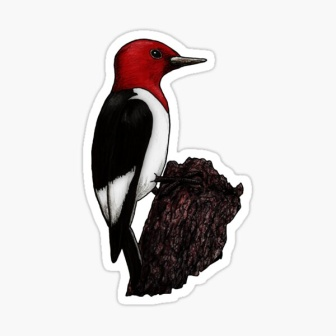What can you infer about the environment from the image? From the detailed depiction of the woodpecker and the tree stump, we can infer that the environment is a natural, lively forest likely abundant with various forms of wildlife. The presence of the woodpecker, which is usually found in wooded areas, suggests that there are plenty of trees, branches, and sources of food such as insects. The textured and aged appearance of the tree stump implies a mature forest setting, where trees have been growing and cycling through life stages for many years. The overall harmony between the bird and its perching stump suggests a peaceful and balanced ecosystem, likely teeming with flora and fauna. What if the woodpecker had a mystical adventure? Describe its journey fully. In a time not far removed from the whispers of legend, Ruby the red-headed woodpecker embarked on an extraordinary adventure. One misty morning, as she pecked on her favorite tree stump, she discovered a hidden path illuminated by a soft, otherworldly glow. Curiosity piqued, Ruby followed this shimmering trail, and soon found herself in an enchanted forest. This was no ordinary forest; the trees were enormous, their branches entwined to form a living canopy that glittered with bioluminescent flowers. As Ruby ventured deeper, she encountered mythical creatures - fairies dancing around mushrooms, ethereal deer with antlers that glowed like the moon, and wise old owls that spoke in riddles. The air was filled with a magical energy that made Ruby's feathers tingle. She arrived at an ancient tree, larger than any she had ever seen, with a hollow entrance guarded by a silver fox. The fox, sensing Ruby’s pure heart, allowed her to enter. Inside, she discovered a hidden sanctuary where the spirits of nature whispered secrets of the forest. They bestowed upon Ruby a special gift: the power to sing notes that could heal the forest and summon rain. Armed with this newfound ability, Ruby flew back home, using her song to nurture the land, heal injured animals, and ensure the balance of her beloved forest. And so, Ruby the red-headed woodpecker became the guardian of the enchanted forest, a legend among all who dwelled there. 